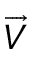<formula> <loc_0><loc_0><loc_500><loc_500>\overrightarrow { V }</formula> 